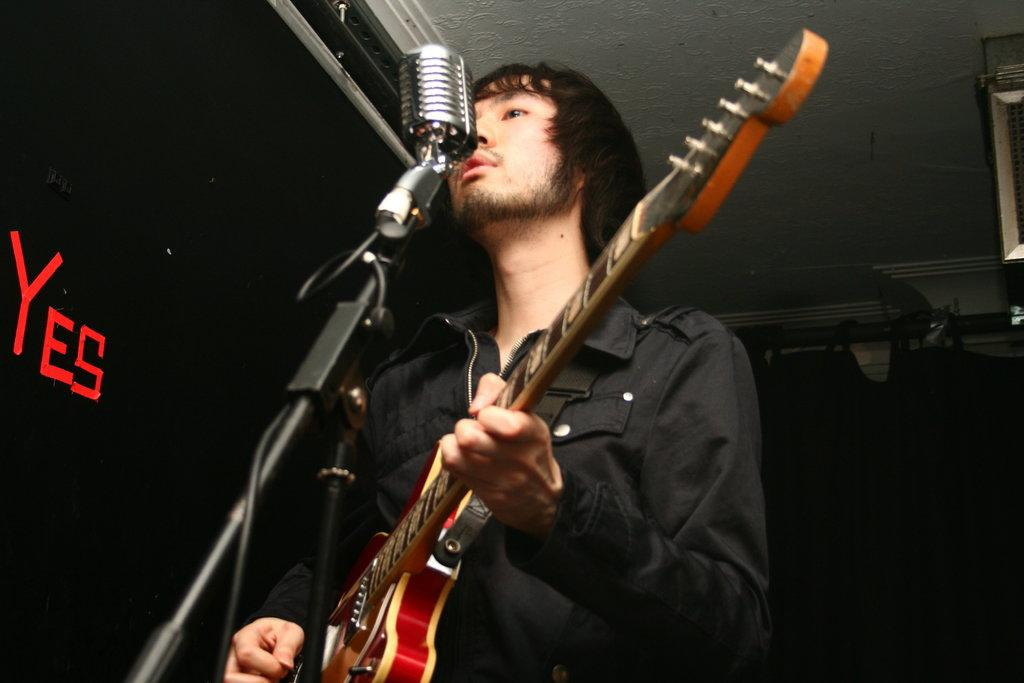Who is the main subject in the image? There is a man in the image. What is the man wearing? The man is wearing a black jacket. What is the man doing in the image? The man is playing a guitar and singing into a microphone. What can be seen hanging from the ceiling on either side of the man? There are black curtains hanging from the ceiling on either side of the man. How many flies are buzzing around the man's head in the image? There are no flies present in the image. What type of cloth is being used to create the curtains in the image? The provided facts do not mention the type of cloth used for the curtains. 